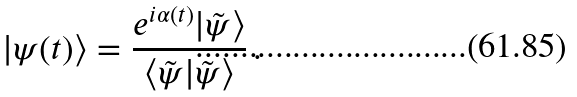Convert formula to latex. <formula><loc_0><loc_0><loc_500><loc_500>| \psi ( t ) \rangle = \frac { e ^ { i \alpha ( t ) } | \tilde { \psi } \rangle } { \langle \tilde { \psi } | \tilde { \psi } \rangle } \, .</formula> 